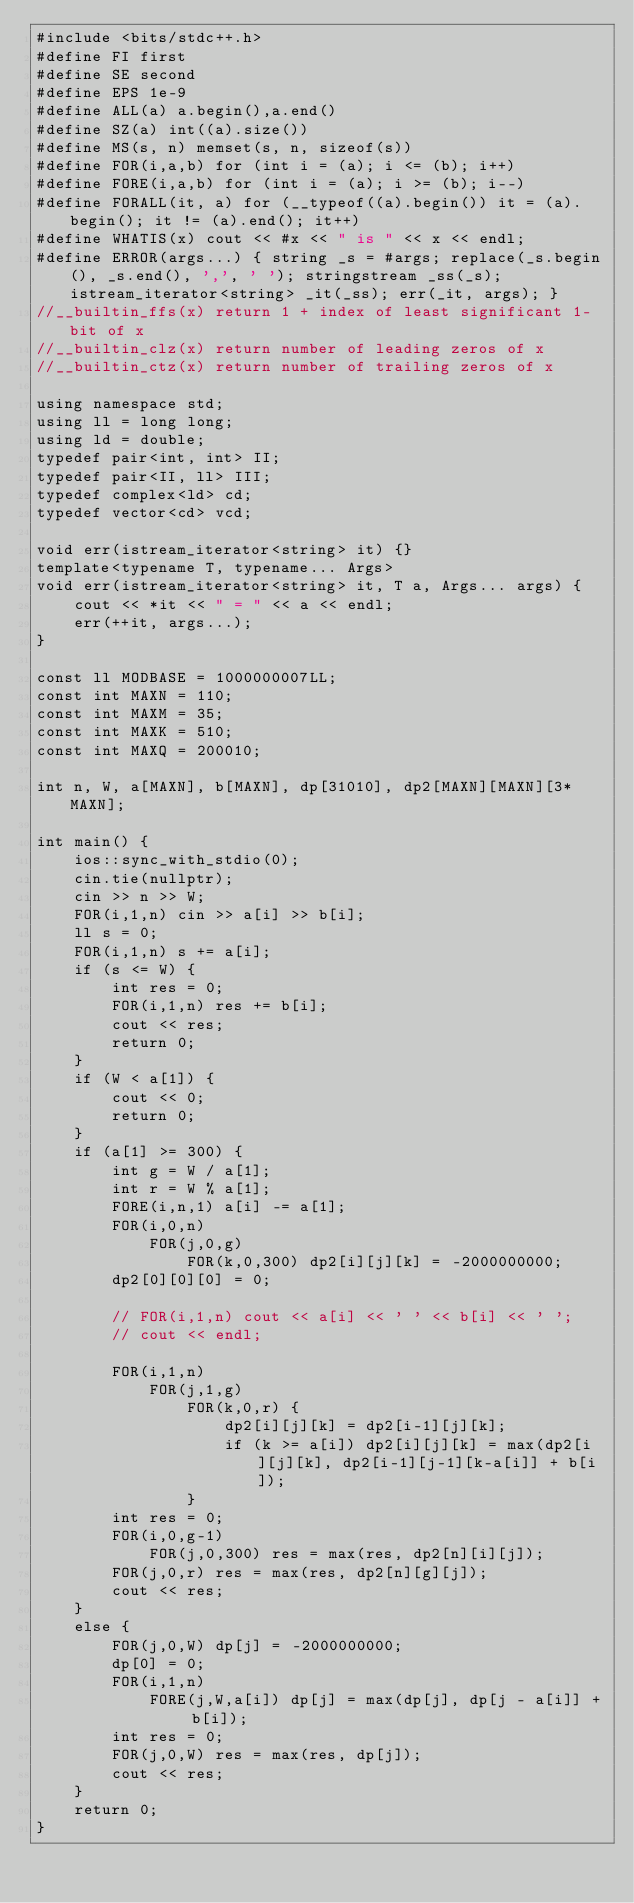Convert code to text. <code><loc_0><loc_0><loc_500><loc_500><_C++_>#include <bits/stdc++.h>
#define FI first
#define SE second
#define EPS 1e-9
#define ALL(a) a.begin(),a.end()
#define SZ(a) int((a).size())
#define MS(s, n) memset(s, n, sizeof(s))
#define FOR(i,a,b) for (int i = (a); i <= (b); i++)
#define FORE(i,a,b) for (int i = (a); i >= (b); i--)
#define FORALL(it, a) for (__typeof((a).begin()) it = (a).begin(); it != (a).end(); it++)
#define WHATIS(x) cout << #x << " is " << x << endl;
#define ERROR(args...) { string _s = #args; replace(_s.begin(), _s.end(), ',', ' '); stringstream _ss(_s); istream_iterator<string> _it(_ss); err(_it, args); }
//__builtin_ffs(x) return 1 + index of least significant 1-bit of x
//__builtin_clz(x) return number of leading zeros of x
//__builtin_ctz(x) return number of trailing zeros of x

using namespace std;
using ll = long long;
using ld = double;
typedef pair<int, int> II;
typedef pair<II, ll> III;
typedef complex<ld> cd;
typedef vector<cd> vcd;

void err(istream_iterator<string> it) {}
template<typename T, typename... Args>
void err(istream_iterator<string> it, T a, Args... args) {
    cout << *it << " = " << a << endl;
    err(++it, args...);
}

const ll MODBASE = 1000000007LL;
const int MAXN = 110;
const int MAXM = 35;
const int MAXK = 510;
const int MAXQ = 200010;

int n, W, a[MAXN], b[MAXN], dp[31010], dp2[MAXN][MAXN][3*MAXN];

int main() {
    ios::sync_with_stdio(0);
    cin.tie(nullptr);
    cin >> n >> W;
    FOR(i,1,n) cin >> a[i] >> b[i];
    ll s = 0;
    FOR(i,1,n) s += a[i];
    if (s <= W) {
        int res = 0;
        FOR(i,1,n) res += b[i];
        cout << res;
        return 0;
    }
    if (W < a[1]) {
        cout << 0;
        return 0;
    }
    if (a[1] >= 300) {
        int g = W / a[1];
        int r = W % a[1];
        FORE(i,n,1) a[i] -= a[1];
        FOR(i,0,n)
            FOR(j,0,g)
                FOR(k,0,300) dp2[i][j][k] = -2000000000;
        dp2[0][0][0] = 0;

        // FOR(i,1,n) cout << a[i] << ' ' << b[i] << ' ';
        // cout << endl;

        FOR(i,1,n)
            FOR(j,1,g)
                FOR(k,0,r) {
                    dp2[i][j][k] = dp2[i-1][j][k];
                    if (k >= a[i]) dp2[i][j][k] = max(dp2[i][j][k], dp2[i-1][j-1][k-a[i]] + b[i]);
                }
        int res = 0;
        FOR(i,0,g-1) 
            FOR(j,0,300) res = max(res, dp2[n][i][j]); 
        FOR(j,0,r) res = max(res, dp2[n][g][j]);
        cout << res;
    }
    else {
        FOR(j,0,W) dp[j] = -2000000000;
        dp[0] = 0;
        FOR(i,1,n)
            FORE(j,W,a[i]) dp[j] = max(dp[j], dp[j - a[i]] + b[i]);
        int res = 0;
        FOR(j,0,W) res = max(res, dp[j]);
        cout << res;
    }
    return 0;
}</code> 